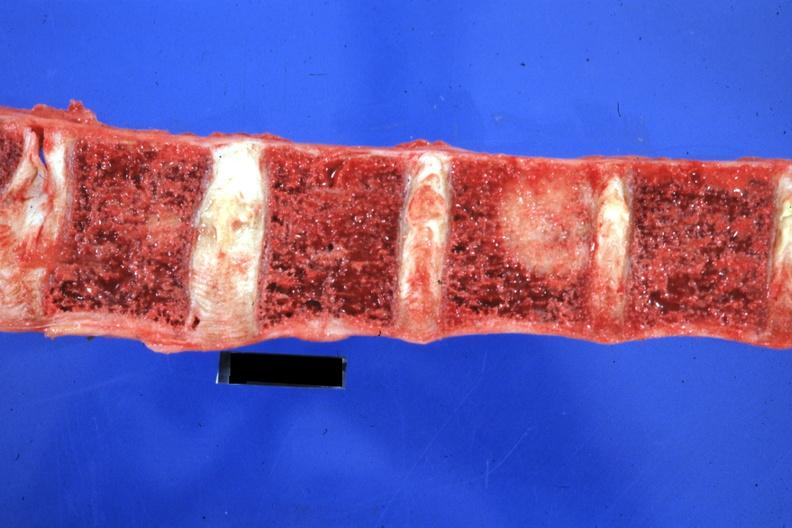does this image show close-up excellent primary tail of pancreas?
Answer the question using a single word or phrase. Yes 